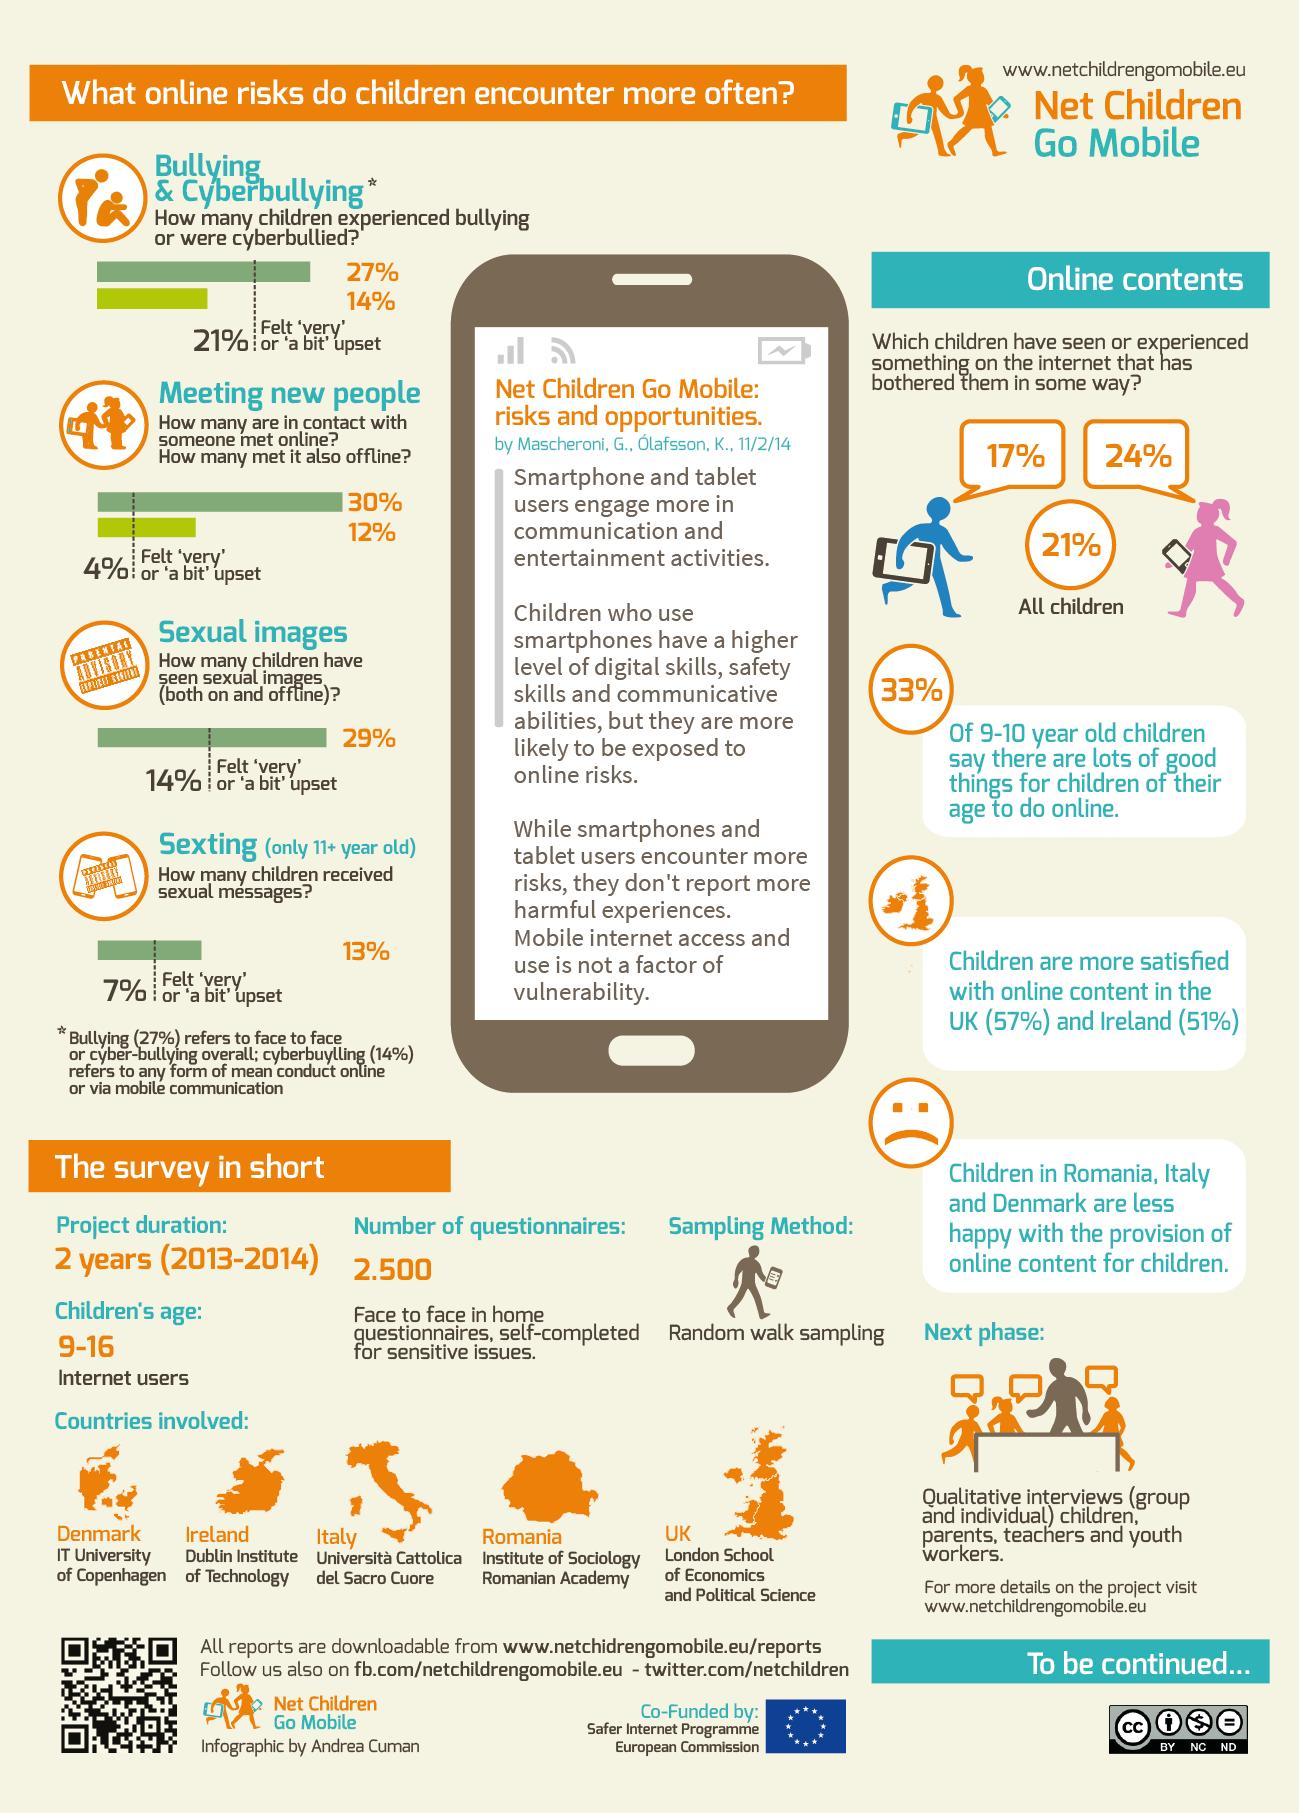Indicate a few pertinent items in this graphic. According to research, 12% of children have met the people they first encountered online. According to the data, approximately 4% of children experienced sadness or slight sadness after meeting new people offline. The London School of Economics and Political Science participated in the survey from the United Kingdom. According to a recent survey in the UK, 43% of children are not satisfied with the online content available to them. According to a recent study, approximately 24% of girls have watched something on the internet and become distracted by it. 